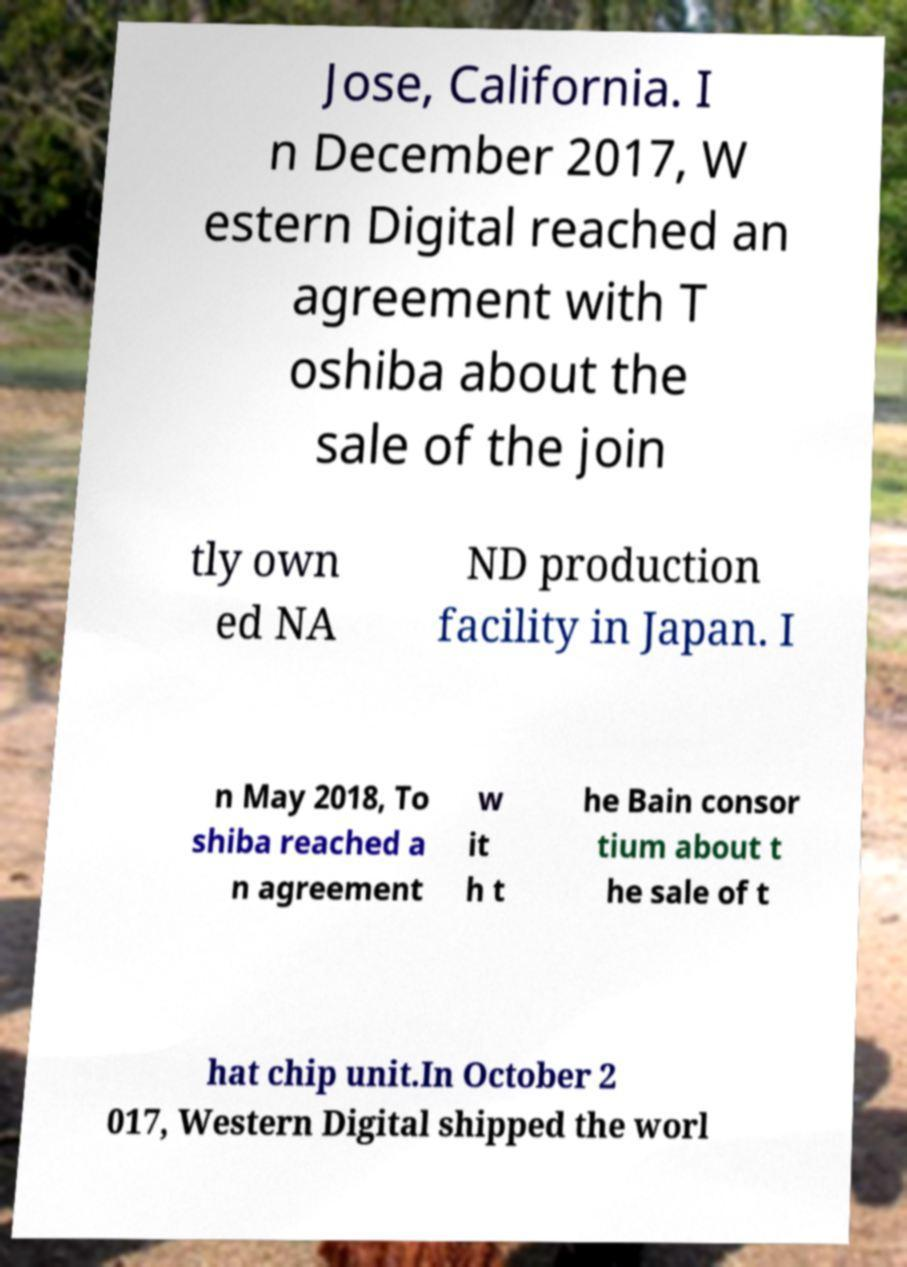Can you read and provide the text displayed in the image?This photo seems to have some interesting text. Can you extract and type it out for me? Jose, California. I n December 2017, W estern Digital reached an agreement with T oshiba about the sale of the join tly own ed NA ND production facility in Japan. I n May 2018, To shiba reached a n agreement w it h t he Bain consor tium about t he sale of t hat chip unit.In October 2 017, Western Digital shipped the worl 